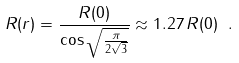<formula> <loc_0><loc_0><loc_500><loc_500>R ( r ) = { \frac { R ( 0 ) } { \cos \sqrt { \frac { \pi } { 2 \sqrt { 3 } } } } } \approx 1 . 2 7 \, R ( 0 ) \ .</formula> 